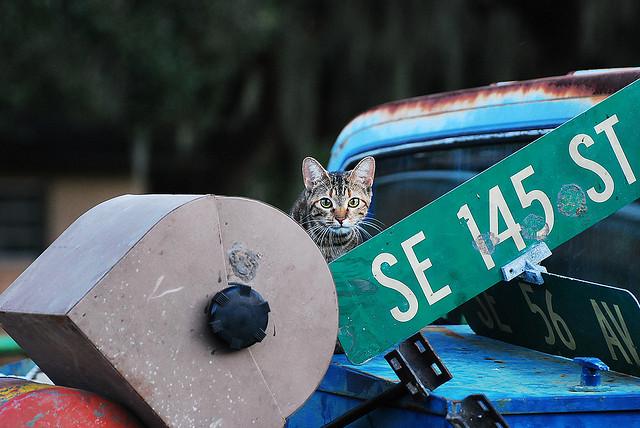Is the cat in front of the sign?
Write a very short answer. No. Is the cat standing near a street sign?
Answer briefly. Yes. What item isn't going to be recycled?
Keep it brief. Cat. 